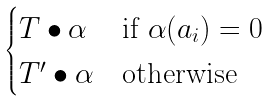<formula> <loc_0><loc_0><loc_500><loc_500>\begin{cases} T \bullet \alpha & \text {if } \alpha ( a _ { i } ) = 0 \\ T ^ { \prime } \bullet \alpha & \text {otherwise} \end{cases}</formula> 